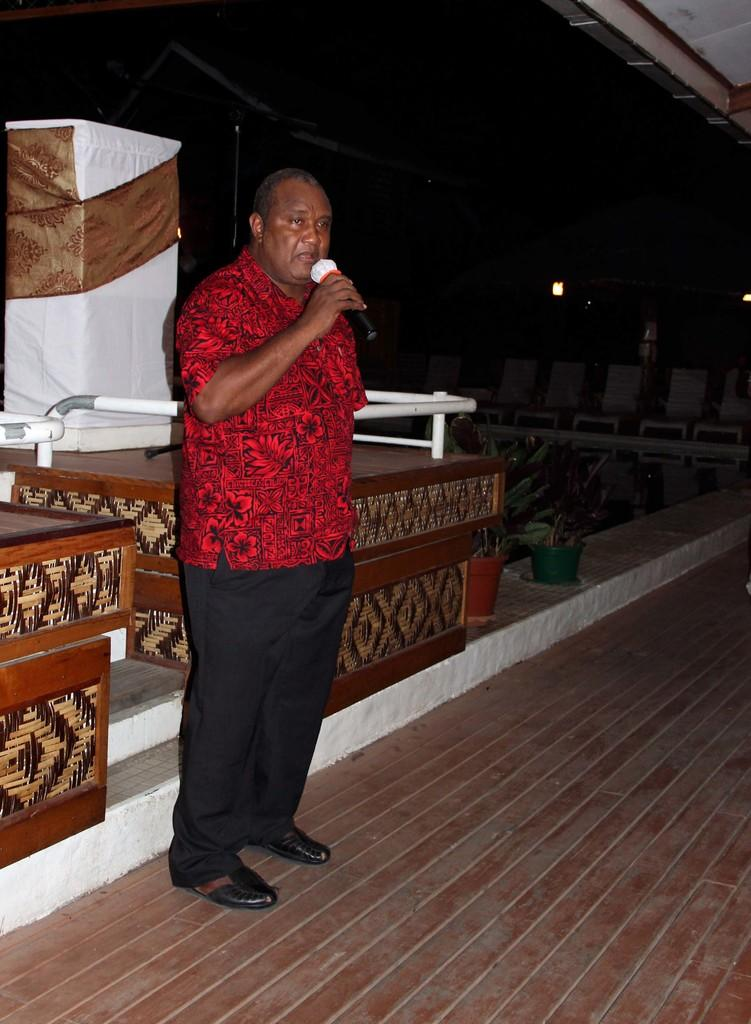What is the man in the foreground of the image doing? The man is standing in the foreground of the image and holding a mic. What can be inferred about the setting of the image? The setting appears to be a stage. What can be seen in the background of the image? There are plants and other objects in the background of the image. How many giants are visible in the image? There are no giants present in the image. What thought is the man having while holding the mic in the image? The image does not provide any information about the man's thoughts, so it cannot be determined from the image. 